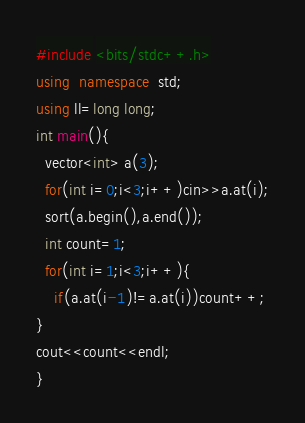Convert code to text. <code><loc_0><loc_0><loc_500><loc_500><_C++_>#include <bits/stdc++.h>
using  namespace  std;
using ll=long long;
int main(){
  vector<int> a(3);
  for(int i=0;i<3;i++)cin>>a.at(i);
  sort(a.begin(),a.end());
  int count=1;
  for(int i=1;i<3;i++){
    if(a.at(i-1)!=a.at(i))count++;
}
cout<<count<<endl;
}</code> 